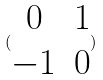<formula> <loc_0><loc_0><loc_500><loc_500>( \begin{matrix} 0 & 1 \\ - 1 & 0 \\ \end{matrix} )</formula> 